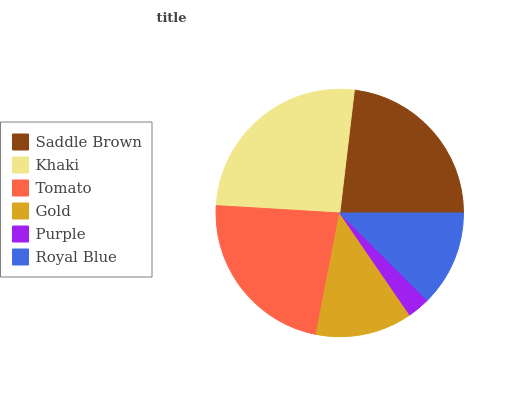Is Purple the minimum?
Answer yes or no. Yes. Is Khaki the maximum?
Answer yes or no. Yes. Is Tomato the minimum?
Answer yes or no. No. Is Tomato the maximum?
Answer yes or no. No. Is Khaki greater than Tomato?
Answer yes or no. Yes. Is Tomato less than Khaki?
Answer yes or no. Yes. Is Tomato greater than Khaki?
Answer yes or no. No. Is Khaki less than Tomato?
Answer yes or no. No. Is Tomato the high median?
Answer yes or no. Yes. Is Gold the low median?
Answer yes or no. Yes. Is Purple the high median?
Answer yes or no. No. Is Khaki the low median?
Answer yes or no. No. 